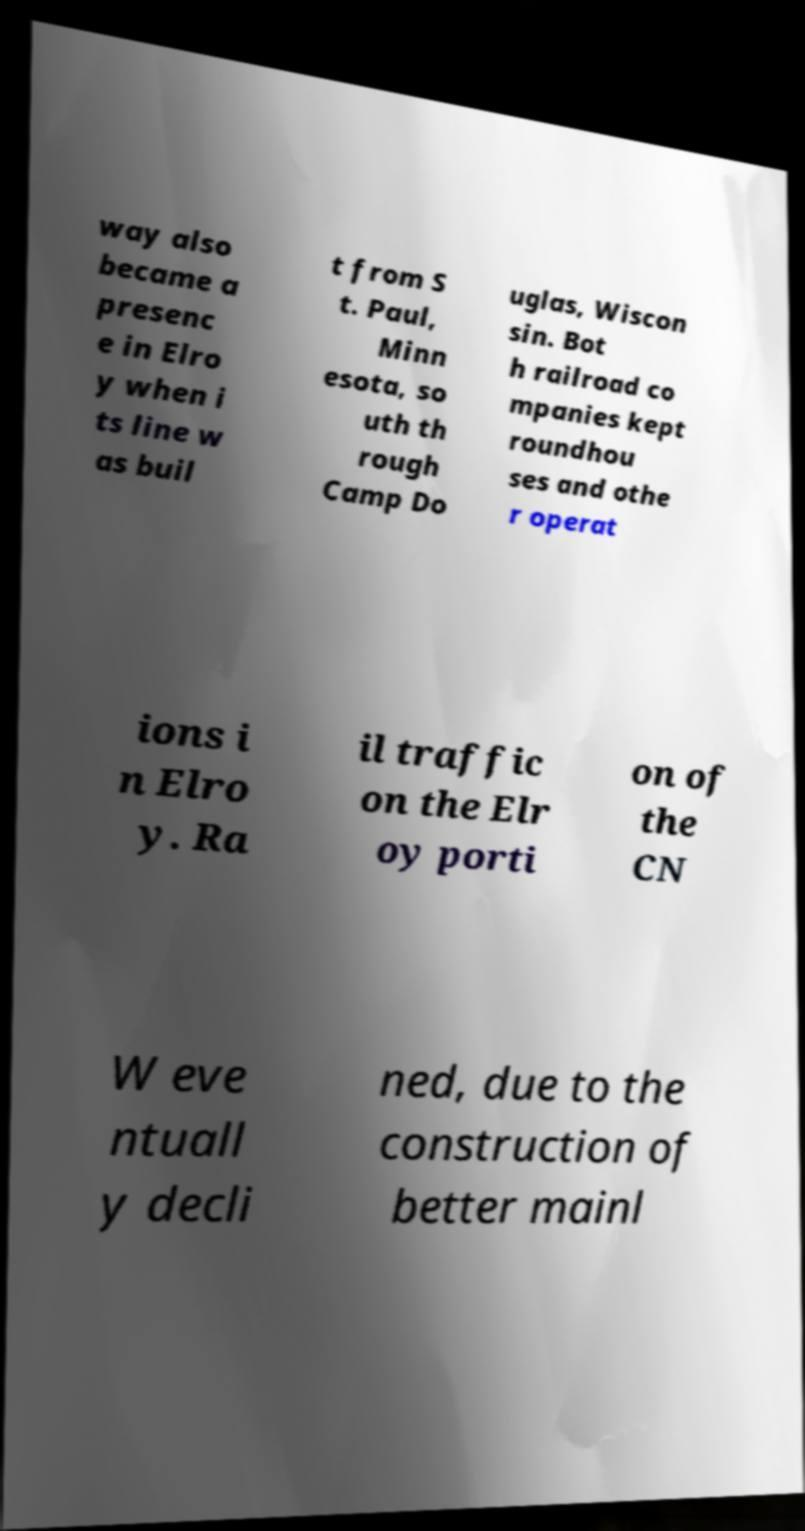Could you assist in decoding the text presented in this image and type it out clearly? way also became a presenc e in Elro y when i ts line w as buil t from S t. Paul, Minn esota, so uth th rough Camp Do uglas, Wiscon sin. Bot h railroad co mpanies kept roundhou ses and othe r operat ions i n Elro y. Ra il traffic on the Elr oy porti on of the CN W eve ntuall y decli ned, due to the construction of better mainl 